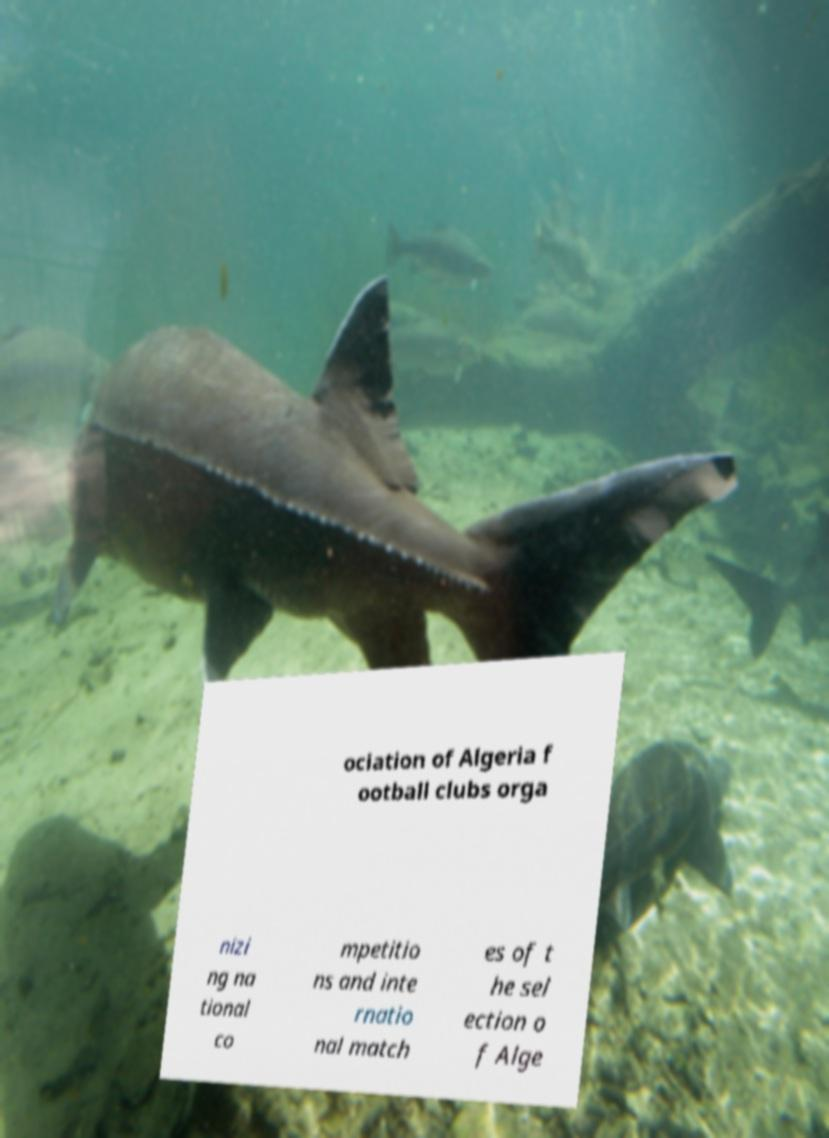Please identify and transcribe the text found in this image. ociation of Algeria f ootball clubs orga nizi ng na tional co mpetitio ns and inte rnatio nal match es of t he sel ection o f Alge 